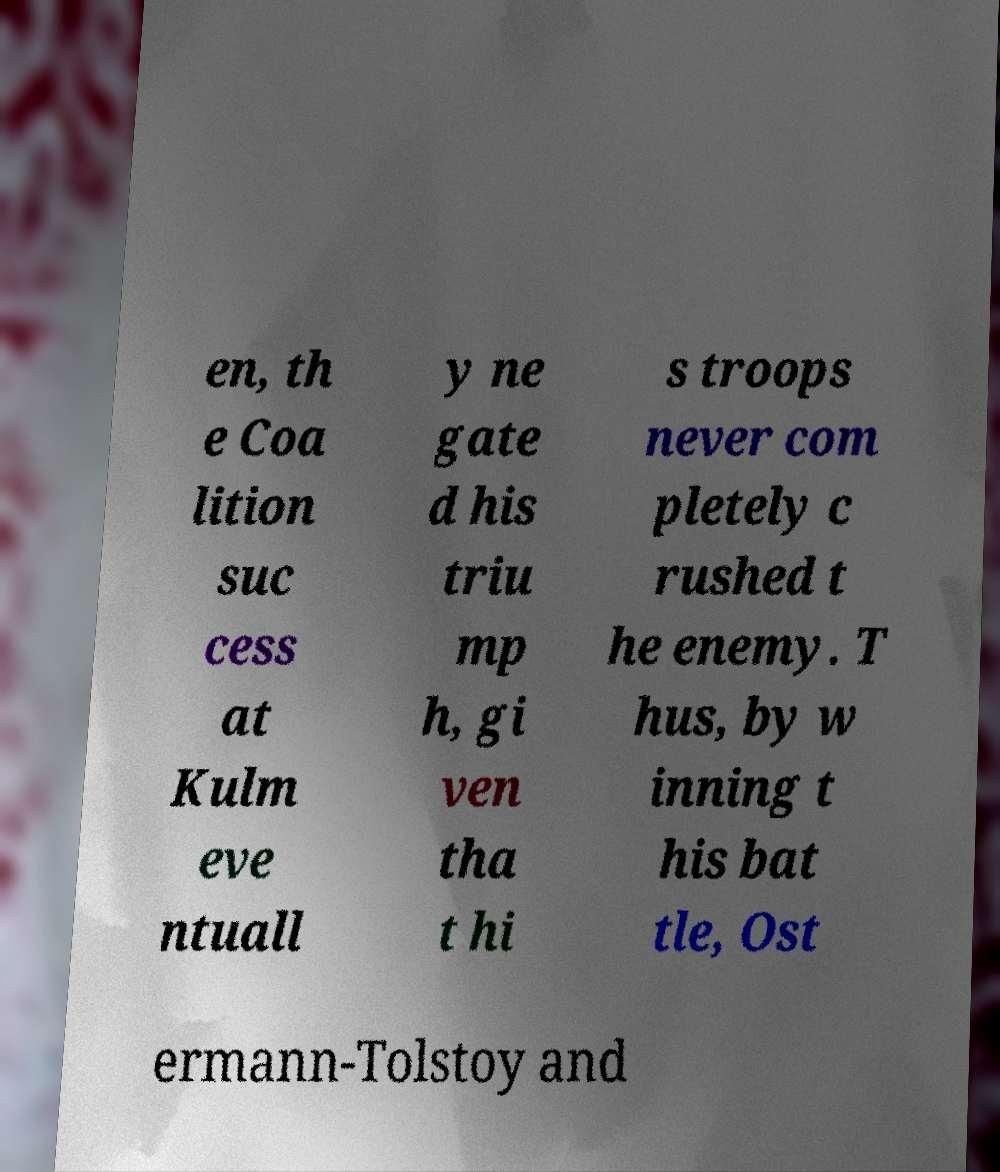Could you assist in decoding the text presented in this image and type it out clearly? en, th e Coa lition suc cess at Kulm eve ntuall y ne gate d his triu mp h, gi ven tha t hi s troops never com pletely c rushed t he enemy. T hus, by w inning t his bat tle, Ost ermann-Tolstoy and 